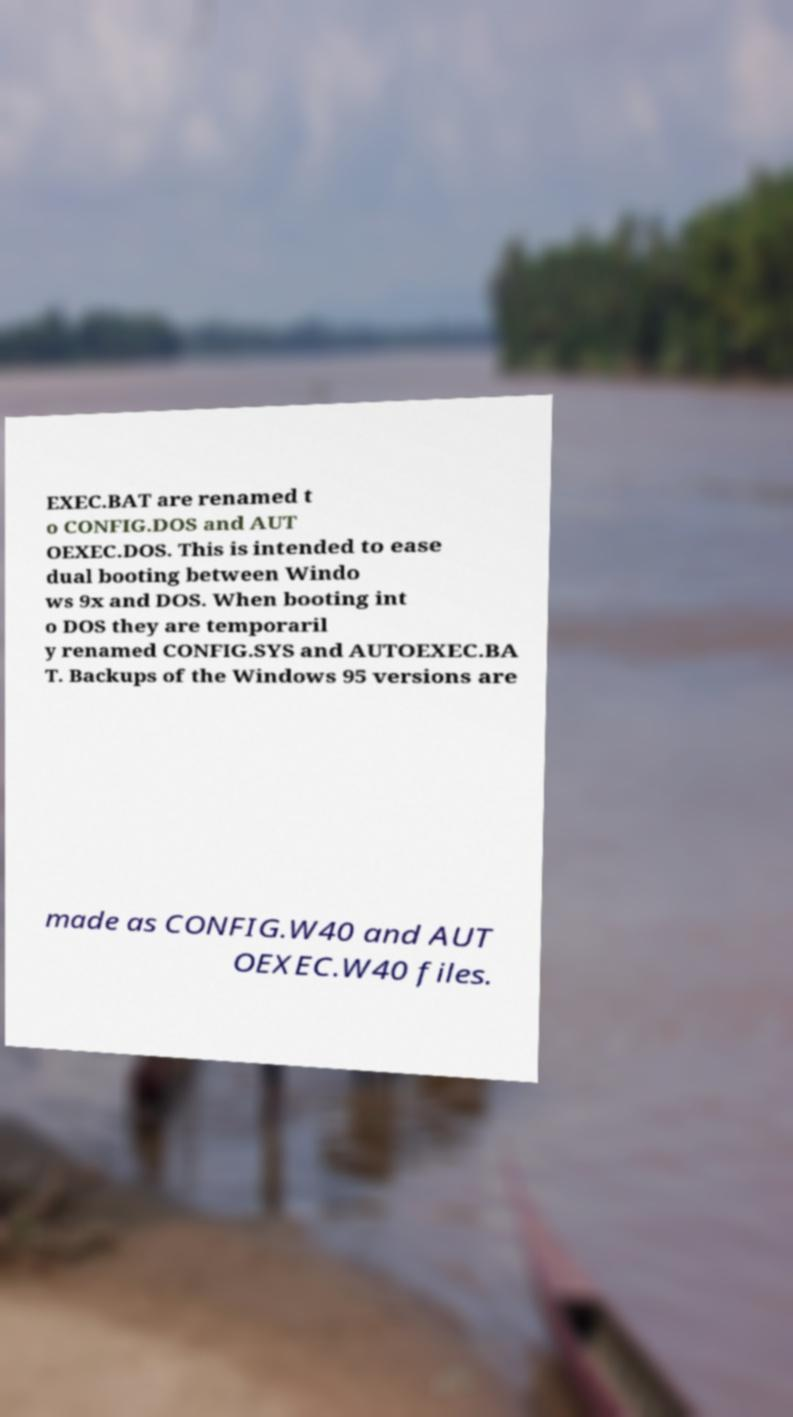I need the written content from this picture converted into text. Can you do that? EXEC.BAT are renamed t o CONFIG.DOS and AUT OEXEC.DOS. This is intended to ease dual booting between Windo ws 9x and DOS. When booting int o DOS they are temporaril y renamed CONFIG.SYS and AUTOEXEC.BA T. Backups of the Windows 95 versions are made as CONFIG.W40 and AUT OEXEC.W40 files. 